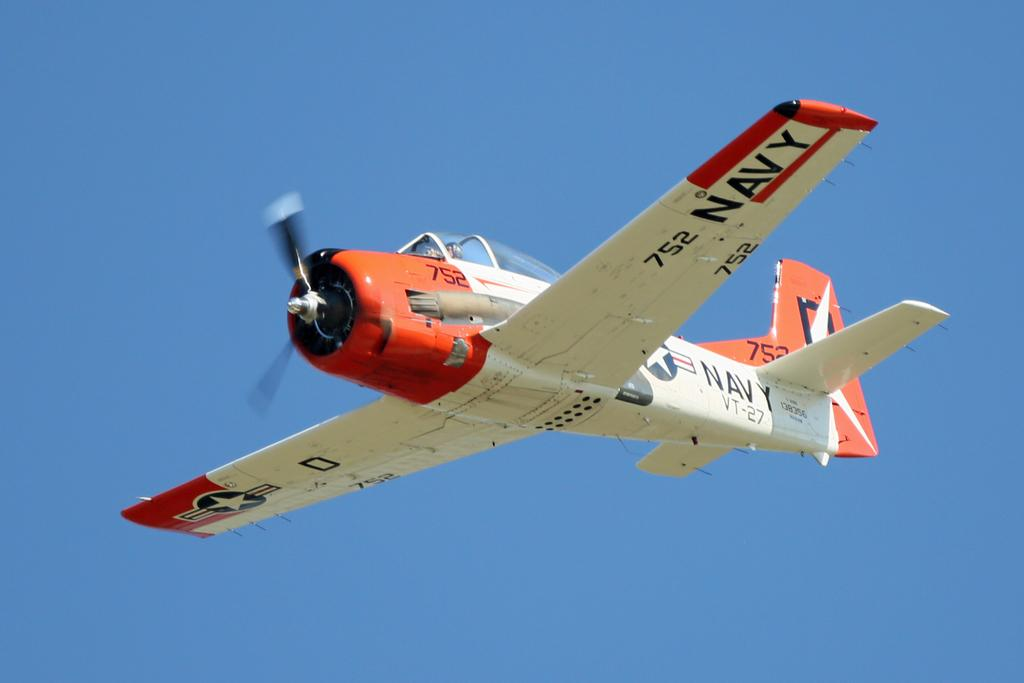<image>
Present a compact description of the photo's key features. An aerial shot of a plane with the word Navy on one of it's wings 